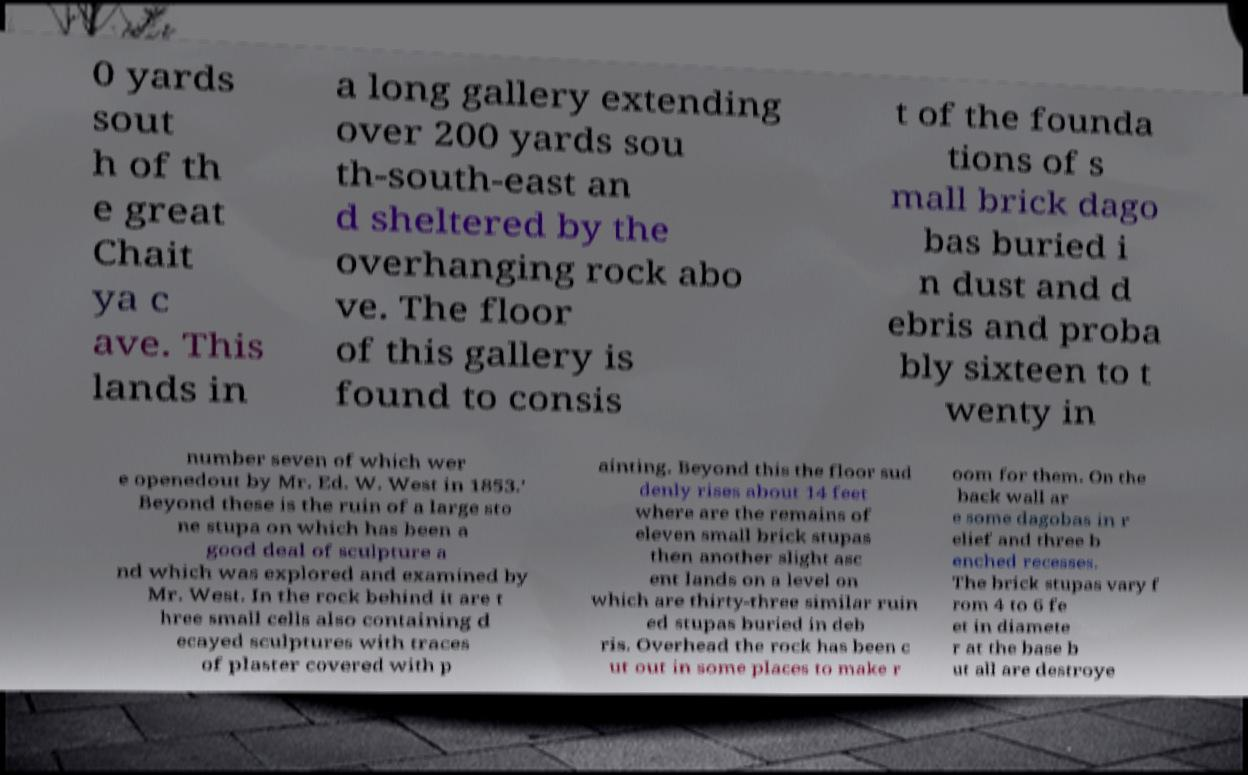Could you assist in decoding the text presented in this image and type it out clearly? 0 yards sout h of th e great Chait ya c ave. This lands in a long gallery extending over 200 yards sou th-south-east an d sheltered by the overhanging rock abo ve. The floor of this gallery is found to consis t of the founda tions of s mall brick dago bas buried i n dust and d ebris and proba bly sixteen to t wenty in number seven of which wer e openedout by Mr. Ed. W. West in 1853.' Beyond these is the ruin of a large sto ne stupa on which has been a good deal of sculpture a nd which was explored and examined by Mr. West. In the rock behind it are t hree small cells also containing d ecayed sculptures with traces of plaster covered with p ainting. Beyond this the floor sud denly rises about 14 feet where are the remains of eleven small brick stupas then another slight asc ent lands on a level on which are thirty-three similar ruin ed stupas buried in deb ris. Overhead the rock has been c ut out in some places to make r oom for them. On the back wall ar e some dagobas in r elief and three b enched recesses. The brick stupas vary f rom 4 to 6 fe et in diamete r at the base b ut all are destroye 